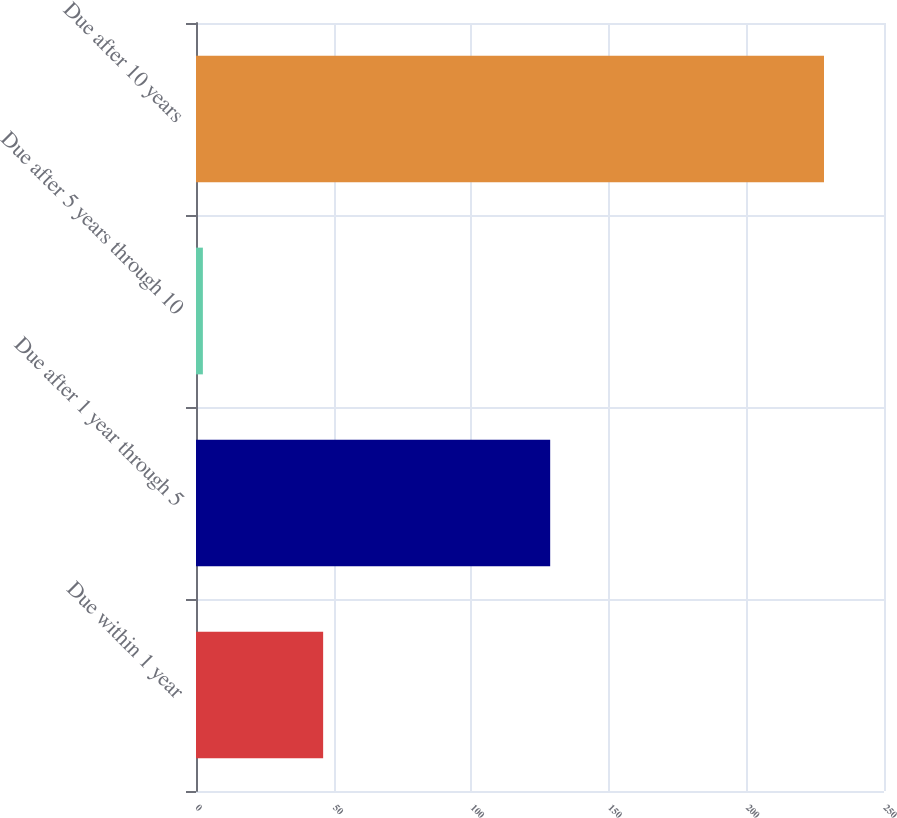<chart> <loc_0><loc_0><loc_500><loc_500><bar_chart><fcel>Due within 1 year<fcel>Due after 1 year through 5<fcel>Due after 5 years through 10<fcel>Due after 10 years<nl><fcel>46.2<fcel>128.7<fcel>2.5<fcel>228.2<nl></chart> 